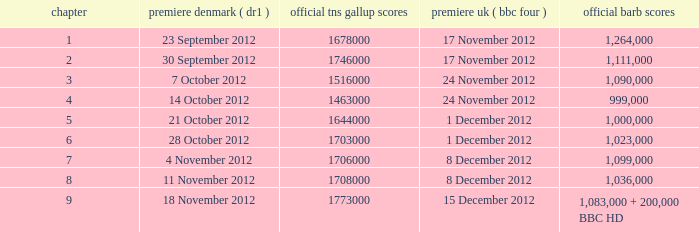When was the episode with a 1,036,000 BARB rating first aired in Denmark? 11 November 2012. 